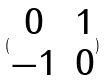<formula> <loc_0><loc_0><loc_500><loc_500>( \begin{matrix} 0 & 1 \\ - 1 & 0 \end{matrix} )</formula> 